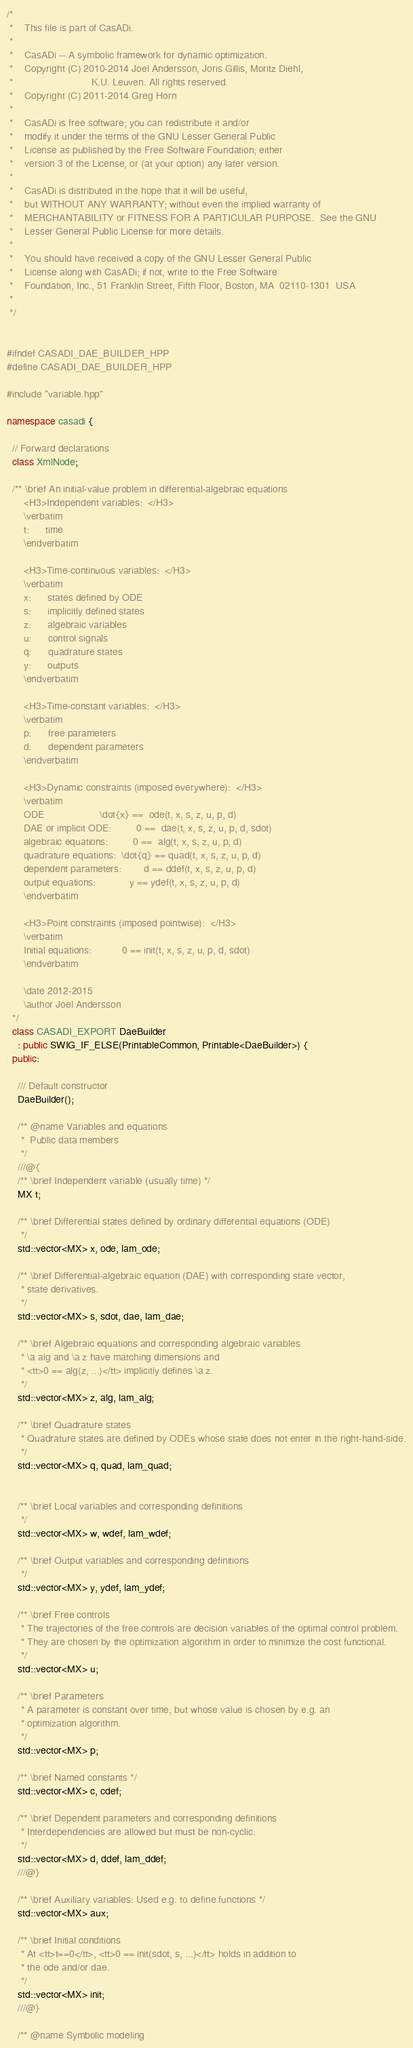Convert code to text. <code><loc_0><loc_0><loc_500><loc_500><_C++_>/*
 *    This file is part of CasADi.
 *
 *    CasADi -- A symbolic framework for dynamic optimization.
 *    Copyright (C) 2010-2014 Joel Andersson, Joris Gillis, Moritz Diehl,
 *                            K.U. Leuven. All rights reserved.
 *    Copyright (C) 2011-2014 Greg Horn
 *
 *    CasADi is free software; you can redistribute it and/or
 *    modify it under the terms of the GNU Lesser General Public
 *    License as published by the Free Software Foundation; either
 *    version 3 of the License, or (at your option) any later version.
 *
 *    CasADi is distributed in the hope that it will be useful,
 *    but WITHOUT ANY WARRANTY; without even the implied warranty of
 *    MERCHANTABILITY or FITNESS FOR A PARTICULAR PURPOSE.  See the GNU
 *    Lesser General Public License for more details.
 *
 *    You should have received a copy of the GNU Lesser General Public
 *    License along with CasADi; if not, write to the Free Software
 *    Foundation, Inc., 51 Franklin Street, Fifth Floor, Boston, MA  02110-1301  USA
 *
 */


#ifndef CASADI_DAE_BUILDER_HPP
#define CASADI_DAE_BUILDER_HPP

#include "variable.hpp"

namespace casadi {

  // Forward declarations
  class XmlNode;

  /** \brief An initial-value problem in differential-algebraic equations
      <H3>Independent variables:  </H3>
      \verbatim
      t:      time
      \endverbatim

      <H3>Time-continuous variables:  </H3>
      \verbatim
      x:      states defined by ODE
      s:      implicitly defined states
      z:      algebraic variables
      u:      control signals
      q:      quadrature states
      y:      outputs
      \endverbatim

      <H3>Time-constant variables:  </H3>
      \verbatim
      p:      free parameters
      d:      dependent parameters
      \endverbatim

      <H3>Dynamic constraints (imposed everywhere):  </H3>
      \verbatim
      ODE                    \dot{x} ==  ode(t, x, s, z, u, p, d)
      DAE or implicit ODE:         0 ==  dae(t, x, s, z, u, p, d, sdot)
      algebraic equations:         0 ==  alg(t, x, s, z, u, p, d)
      quadrature equations:  \dot{q} == quad(t, x, s, z, u, p, d)
      dependent parameters:        d == ddef(t, x, s, z, u, p, d)
      output equations:            y == ydef(t, x, s, z, u, p, d)
      \endverbatim

      <H3>Point constraints (imposed pointwise):  </H3>
      \verbatim
      Initial equations:           0 == init(t, x, s, z, u, p, d, sdot)
      \endverbatim

      \date 2012-2015
      \author Joel Andersson
  */
  class CASADI_EXPORT DaeBuilder
    : public SWIG_IF_ELSE(PrintableCommon, Printable<DaeBuilder>) {
  public:

    /// Default constructor
    DaeBuilder();

    /** @name Variables and equations
     *  Public data members
     */
    ///@{
    /** \brief Independent variable (usually time) */
    MX t;

    /** \brief Differential states defined by ordinary differential equations (ODE)
     */
    std::vector<MX> x, ode, lam_ode;

    /** \brief Differential-algebraic equation (DAE) with corresponding state vector,
     * state derivatives.
     */
    std::vector<MX> s, sdot, dae, lam_dae;

    /** \brief Algebraic equations and corresponding algebraic variables
     * \a alg and \a z have matching dimensions and
     * <tt>0 == alg(z, ...)</tt> implicitly defines \a z.
     */
    std::vector<MX> z, alg, lam_alg;

    /** \brief Quadrature states
     * Quadrature states are defined by ODEs whose state does not enter in the right-hand-side.
     */
    std::vector<MX> q, quad, lam_quad;


    /** \brief Local variables and corresponding definitions
     */
    std::vector<MX> w, wdef, lam_wdef;

    /** \brief Output variables and corresponding definitions
     */
    std::vector<MX> y, ydef, lam_ydef;

    /** \brief Free controls
     * The trajectories of the free controls are decision variables of the optimal control problem.
     * They are chosen by the optimization algorithm in order to minimize the cost functional.
     */
    std::vector<MX> u;

    /** \brief Parameters
     * A parameter is constant over time, but whose value is chosen by e.g. an
     * optimization algorithm.
     */
    std::vector<MX> p;

    /** \brief Named constants */
    std::vector<MX> c, cdef;

    /** \brief Dependent parameters and corresponding definitions
     * Interdependencies are allowed but must be non-cyclic.
     */
    std::vector<MX> d, ddef, lam_ddef;
    ///@}

    /** \brief Auxiliary variables: Used e.g. to define functions */
    std::vector<MX> aux;

    /** \brief Initial conditions
     * At <tt>t==0</tt>, <tt>0 == init(sdot, s, ...)</tt> holds in addition to
     * the ode and/or dae.
     */
    std::vector<MX> init;
    ///@}

    /** @name Symbolic modeling</code> 